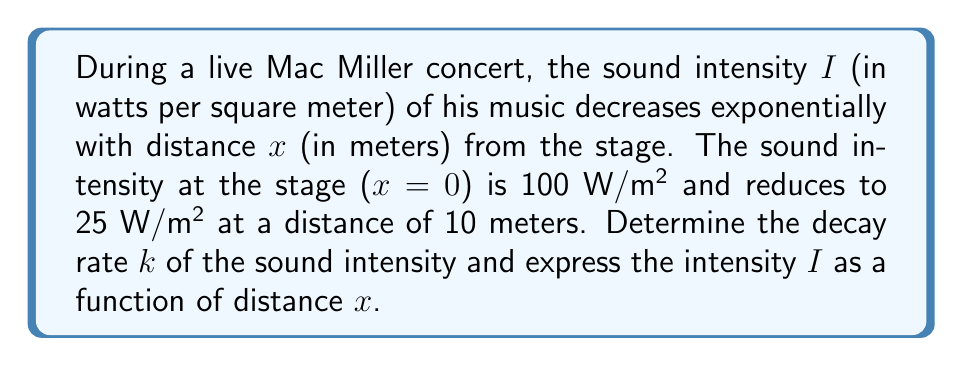Provide a solution to this math problem. To solve this problem, we'll use the exponential decay model for sound intensity:

$$I(x) = I_0 e^{-kx}$$

Where:
$I(x)$ is the sound intensity at distance $x$
$I_0$ is the initial sound intensity (at $x=0$)
$k$ is the decay rate (what we need to find)
$x$ is the distance from the stage

We're given:
$I_0 = 100$ W/m² (intensity at the stage)
$I(10) = 25$ W/m² (intensity at 10 meters)

Let's substitute these values into our equation:

$$25 = 100 e^{-k(10)}$$

Now, let's solve for $k$:

1) Divide both sides by 100:
   $$\frac{25}{100} = e^{-10k}$$

2) Take the natural logarithm of both sides:
   $$\ln(\frac{1}{4}) = -10k$$

3) Simplify:
   $$-\ln(4) = -10k$$

4) Solve for $k$:
   $$k = \frac{\ln(4)}{10} \approx 0.1386$$

Now that we have $k$, we can express $I$ as a function of $x$:

$$I(x) = 100 e^{-0.1386x}$$

This equation represents how the sound intensity of Mac Miller's music decreases with distance from the stage during the live concert.
Answer: The decay rate $k \approx 0.1386$ m⁻¹, and the sound intensity as a function of distance is $I(x) = 100 e^{-0.1386x}$ W/m². 